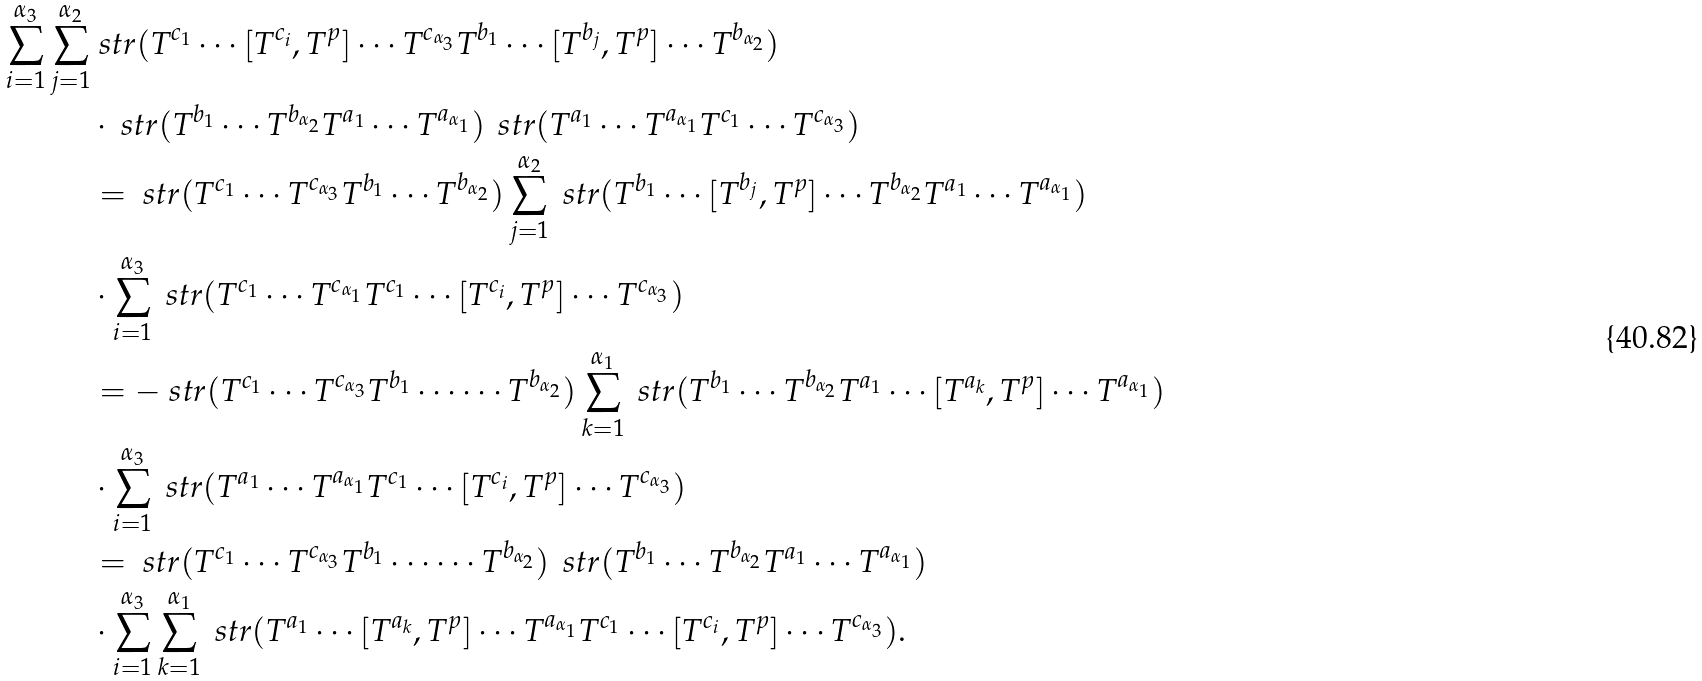<formula> <loc_0><loc_0><loc_500><loc_500>\sum _ { i = 1 } ^ { \alpha _ { 3 } } \sum _ { j = 1 } ^ { \alpha _ { 2 } } & \ s t r ( T ^ { c _ { 1 } } \cdots [ T ^ { c _ { i } } , T ^ { p } ] \cdots T ^ { c _ { \alpha _ { 3 } } } T ^ { b _ { 1 } } \cdots [ T ^ { b _ { j } } , T ^ { p } ] \cdots T ^ { b _ { \alpha _ { 2 } } } ) \\ & \cdot \ s t r ( T ^ { b _ { 1 } } \cdots T ^ { b _ { \alpha _ { 2 } } } T ^ { a _ { 1 } } \cdots T ^ { a _ { \alpha _ { 1 } } } ) \, \ s t r ( T ^ { a _ { 1 } } \cdots T ^ { a _ { \alpha _ { 1 } } } T ^ { c _ { 1 } } \cdots T ^ { c _ { \alpha _ { 3 } } } ) \\ & = \ s t r ( T ^ { c _ { 1 } } \cdots T ^ { c _ { \alpha _ { 3 } } } T ^ { b _ { 1 } } \cdots T ^ { b _ { \alpha _ { 2 } } } ) \sum _ { j = 1 } ^ { \alpha _ { 2 } } \ s t r ( T ^ { b _ { 1 } } \cdots [ T ^ { b _ { j } } , T ^ { p } ] \cdots T ^ { b _ { \alpha _ { 2 } } } T ^ { a _ { 1 } } \cdots T ^ { a _ { \alpha _ { 1 } } } ) \\ & \cdot \sum _ { i = 1 } ^ { \alpha _ { 3 } } \ s t r ( T ^ { c _ { 1 } } \cdots T ^ { c _ { \alpha _ { 1 } } } T ^ { c _ { 1 } } \cdots [ T ^ { c _ { i } } , T ^ { p } ] \cdots T ^ { c _ { \alpha _ { 3 } } } ) \\ & = - \ s t r ( T ^ { c _ { 1 } } \cdots T ^ { c _ { \alpha _ { 3 } } } T ^ { b _ { 1 } } \cdots \cdots T ^ { b _ { \alpha _ { 2 } } } ) \sum _ { k = 1 } ^ { \alpha _ { 1 } } \ s t r ( T ^ { b _ { 1 } } \cdots T ^ { b _ { \alpha _ { 2 } } } T ^ { a _ { 1 } } \cdots [ T ^ { a _ { k } } , T ^ { p } ] \cdots T ^ { a _ { \alpha _ { 1 } } } ) \\ & \cdot \sum _ { i = 1 } ^ { \alpha _ { 3 } } \ s t r ( T ^ { a _ { 1 } } \cdots T ^ { a _ { \alpha _ { 1 } } } T ^ { c _ { 1 } } \cdots [ T ^ { c _ { i } } , T ^ { p } ] \cdots T ^ { c _ { \alpha _ { 3 } } } ) \\ & = \ s t r ( T ^ { c _ { 1 } } \cdots T ^ { c _ { \alpha _ { 3 } } } T ^ { b _ { 1 } } \cdots \cdots T ^ { b _ { \alpha _ { 2 } } } ) \, \ s t r ( T ^ { b _ { 1 } } \cdots T ^ { b _ { \alpha _ { 2 } } } T ^ { a _ { 1 } } \cdots T ^ { a _ { \alpha _ { 1 } } } ) \\ & \cdot \sum _ { i = 1 } ^ { \alpha _ { 3 } } \sum _ { k = 1 } ^ { \alpha _ { 1 } } \ s t r ( T ^ { a _ { 1 } } \cdots [ T ^ { a _ { k } } , T ^ { p } ] \cdots T ^ { a _ { \alpha _ { 1 } } } T ^ { c _ { 1 } } \cdots [ T ^ { c _ { i } } , T ^ { p } ] \cdots T ^ { c _ { \alpha _ { 3 } } } ) .</formula> 